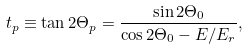<formula> <loc_0><loc_0><loc_500><loc_500>t _ { p } \equiv \tan 2 \Theta _ { p } = \frac { \sin 2 \Theta _ { 0 } } { \cos 2 \Theta _ { 0 } - E / E _ { r } } ,</formula> 